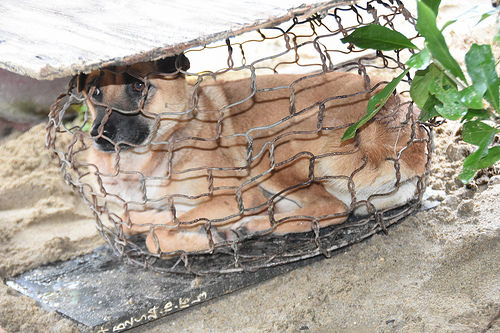<image>
Is there a plant under the dog? No. The plant is not positioned under the dog. The vertical relationship between these objects is different. 